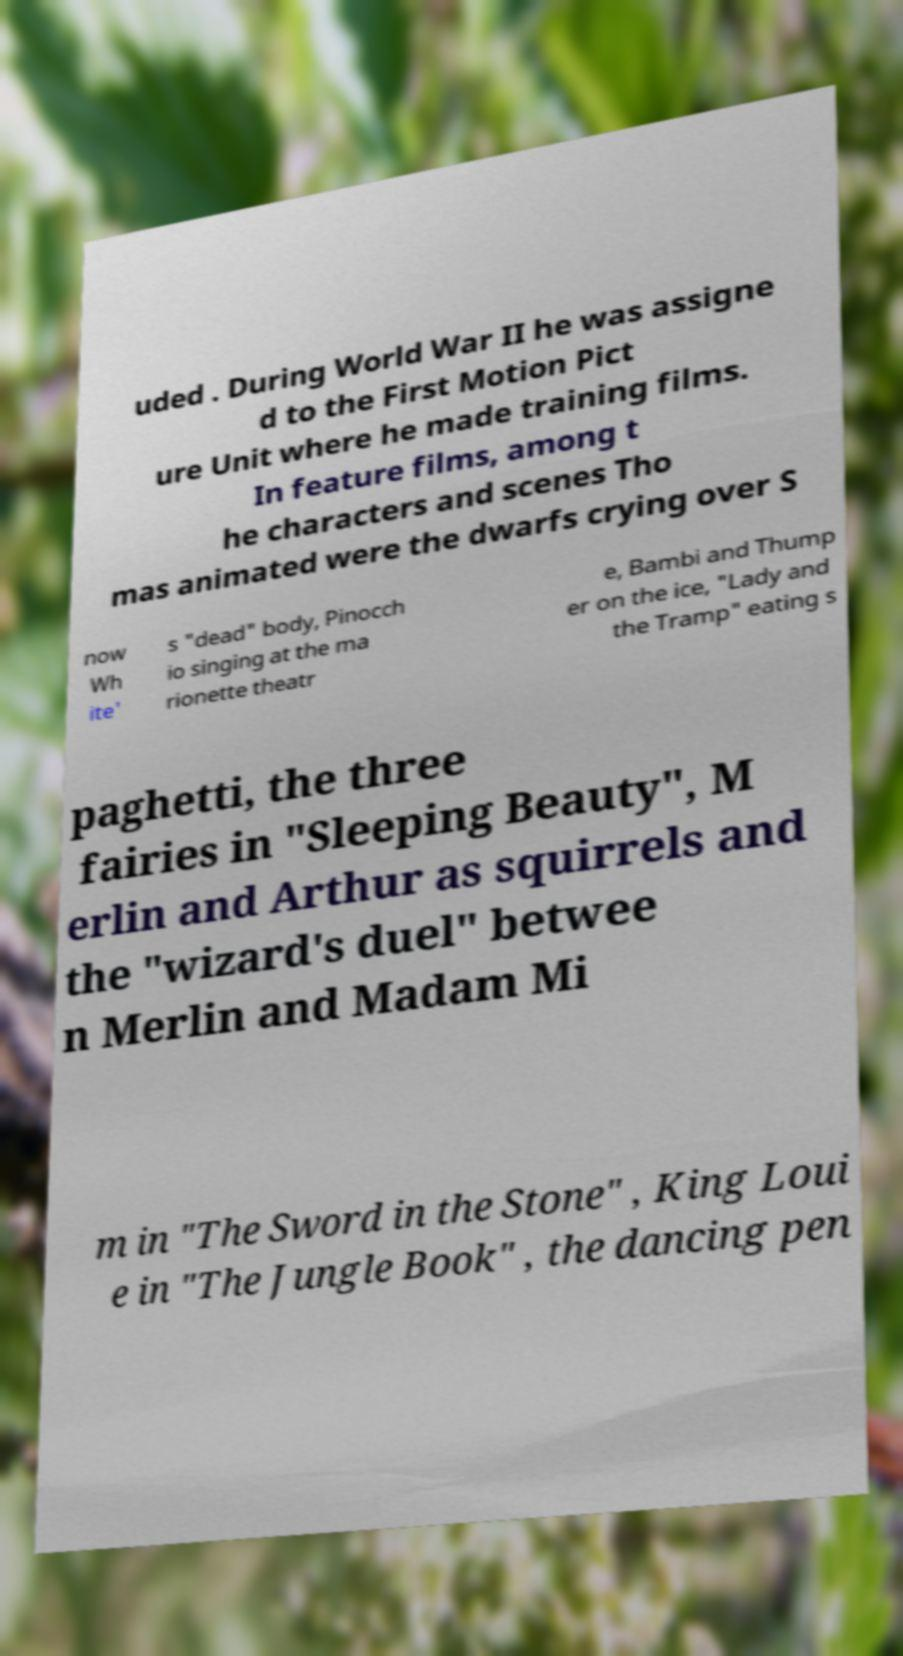Please read and relay the text visible in this image. What does it say? uded . During World War II he was assigne d to the First Motion Pict ure Unit where he made training films. In feature films, among t he characters and scenes Tho mas animated were the dwarfs crying over S now Wh ite' s "dead" body, Pinocch io singing at the ma rionette theatr e, Bambi and Thump er on the ice, "Lady and the Tramp" eating s paghetti, the three fairies in "Sleeping Beauty", M erlin and Arthur as squirrels and the "wizard's duel" betwee n Merlin and Madam Mi m in "The Sword in the Stone" , King Loui e in "The Jungle Book" , the dancing pen 